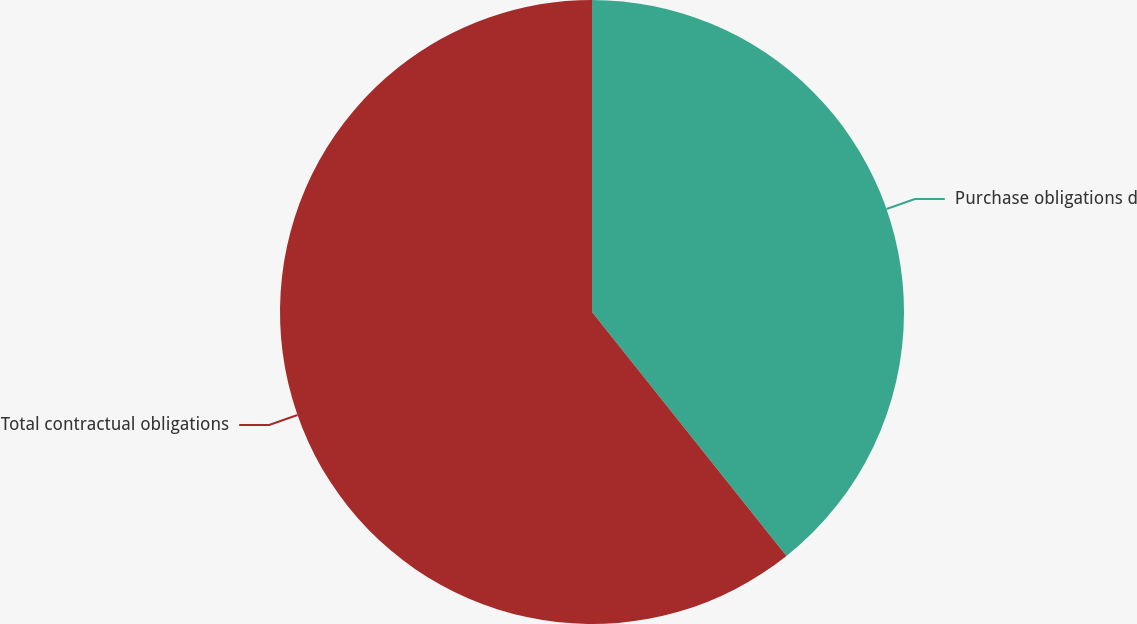Convert chart to OTSL. <chart><loc_0><loc_0><loc_500><loc_500><pie_chart><fcel>Purchase obligations d<fcel>Total contractual obligations<nl><fcel>39.29%<fcel>60.71%<nl></chart> 